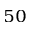Convert formula to latex. <formula><loc_0><loc_0><loc_500><loc_500>_ { 5 0 }</formula> 